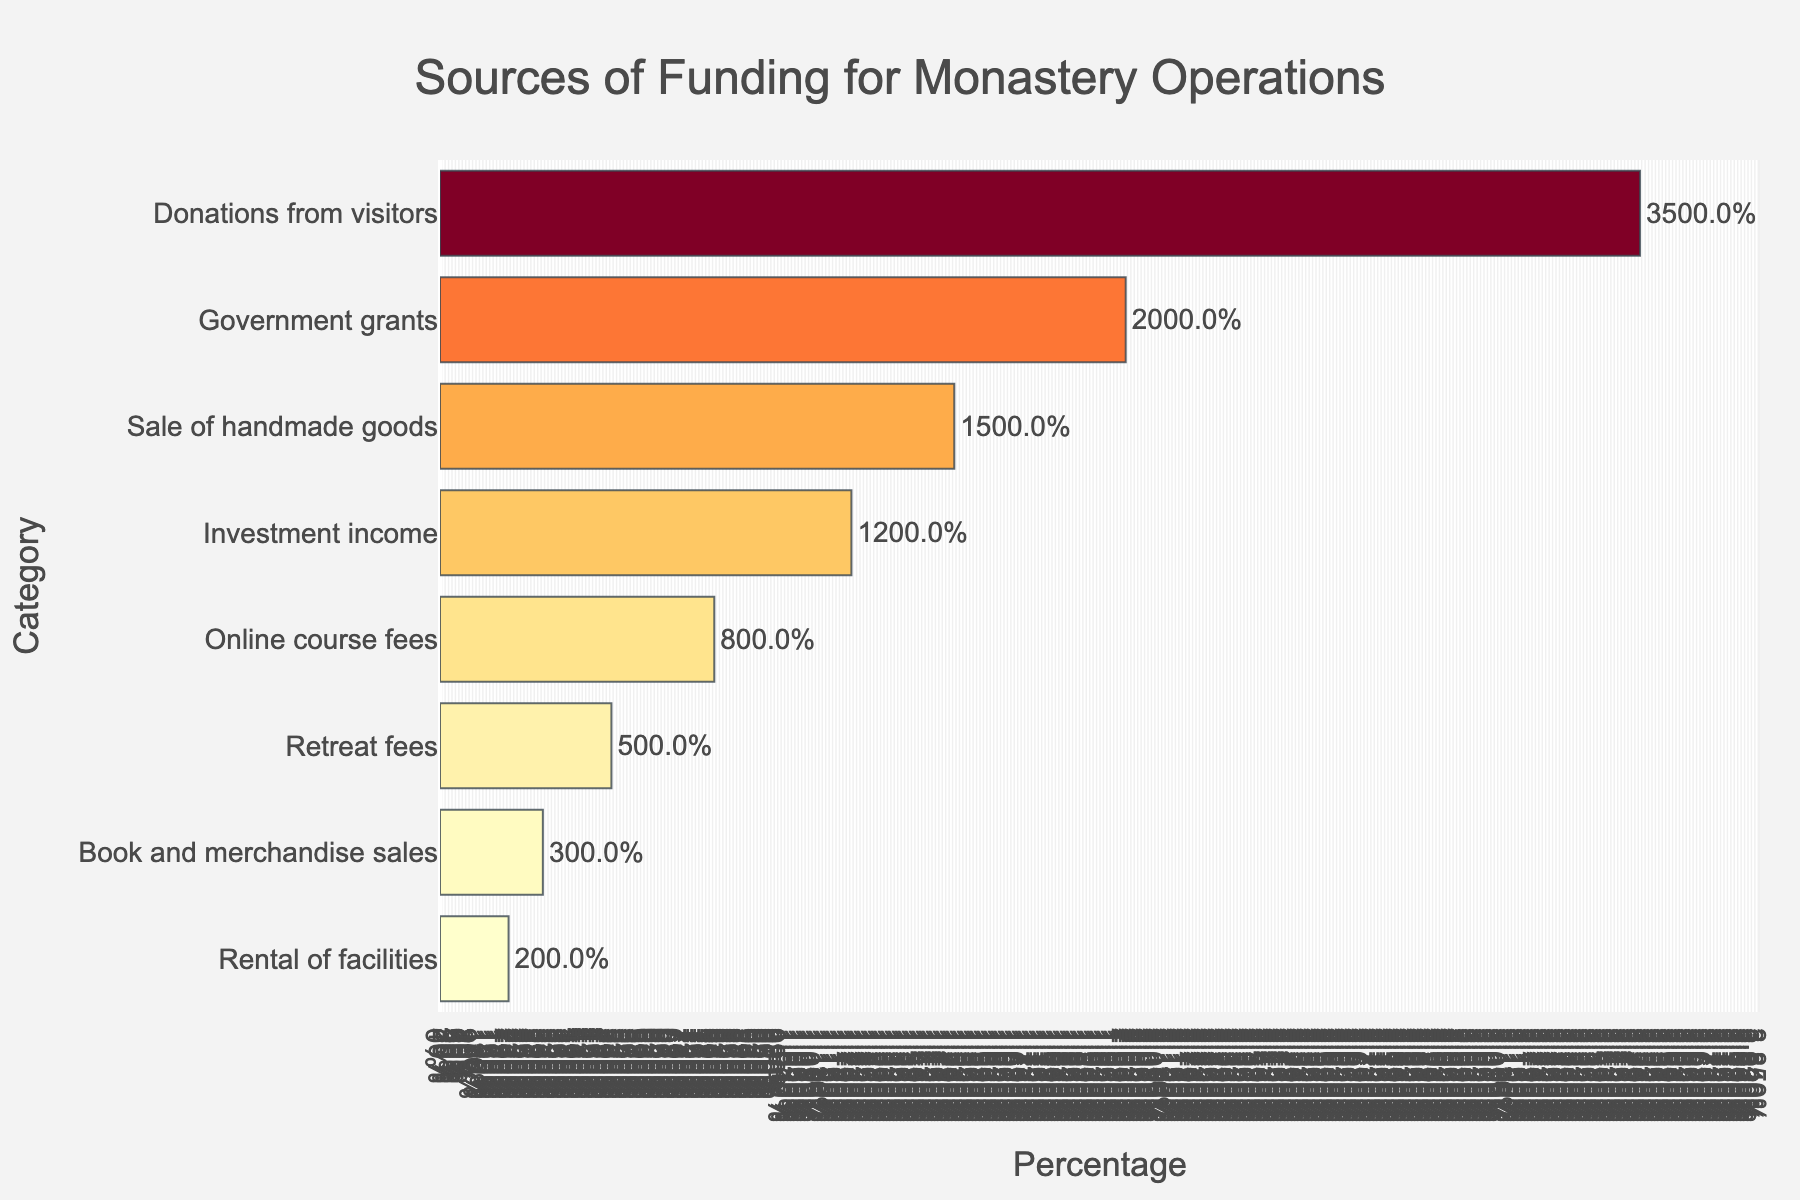Which category contributes the most to the monastery's funding? The bar representing 'Donations from visitors' is the longest, and it has the highest percentage at 35%.
Answer: Donations from visitors Which two categories together contribute the highest percentage to the monastery's funding? The two highest bars are 'Donations from visitors' (35%) and 'Government grants' (20%). Summing these two percentages gives 55%.
Answer: Donations from visitors and Government grants What is the total percentage contribution of the bottom three categories? The percentages of the bottom three categories are 'Rental of facilities' (2%), 'Book and merchandise sales' (3%), and 'Retreat fees' (5%). Summing these gives 2% + 3% + 5% = 10%.
Answer: 10% Which category is three times larger than 'Book and merchandise sales' in percentage contribution? 'Book and merchandise sales' contribute 3%. Three times this amount is 9%. The closest category is 'Online course fees' which contributes 8%, not exactly three times, but the closest.
Answer: Online course fees How much more does 'Donations from visitors' contribute compared to 'Sale of handmade goods'? 'Donations from visitors' contribute 35%, and 'Sale of handmade goods' contribute 15%. The difference is 35% - 15% = 20%.
Answer: 20% What percent of the monastery's funding comes from all categories except 'Donations from visitors'? 'Donations from visitors' contribute 35%. Excluding this, the total is 100% - 35% = 65%.
Answer: 65% Which category has a slightly higher percentage contribution than 'Investment income'? 'Investment income' contributes 12%. The next highest category is 'Sale of handmade goods' at 15%, which is slightly higher.
Answer: Sale of handmade goods If 'Government grants' were to be reduced by 50%, what would be the new total percentage contribution? 'Government grants' contribute 20%. Reducing this by 50% gives 20% / 2 = 10%. The new total percentage would be 100% - 20% + 10% = 90%.
Answer: 90% What is the sum of the contributions of 'Investment income' and 'Online course fees'? 'Investment income' contributes 12%, and 'Online course fees' contribute 8%. The sum is 12% + 8% = 20%.
Answer: 20% Arrange the categories in descending order of their percentage contributions. Based on the chart: 1. Donations from visitors (35%) 2. Government grants (20%) 3. Sale of handmade goods (15%) 4. Investment income (12%) 5. Online course fees (8%) 6. Retreat fees (5%) 7. Book and merchandise sales (3%) 8. Rental of facilities (2%).
Answer: Donations from visitors, Government grants, Sale of handmade goods, Investment income, Online course fees, Retreat fees, Book and merchandise sales, Rental of facilities 